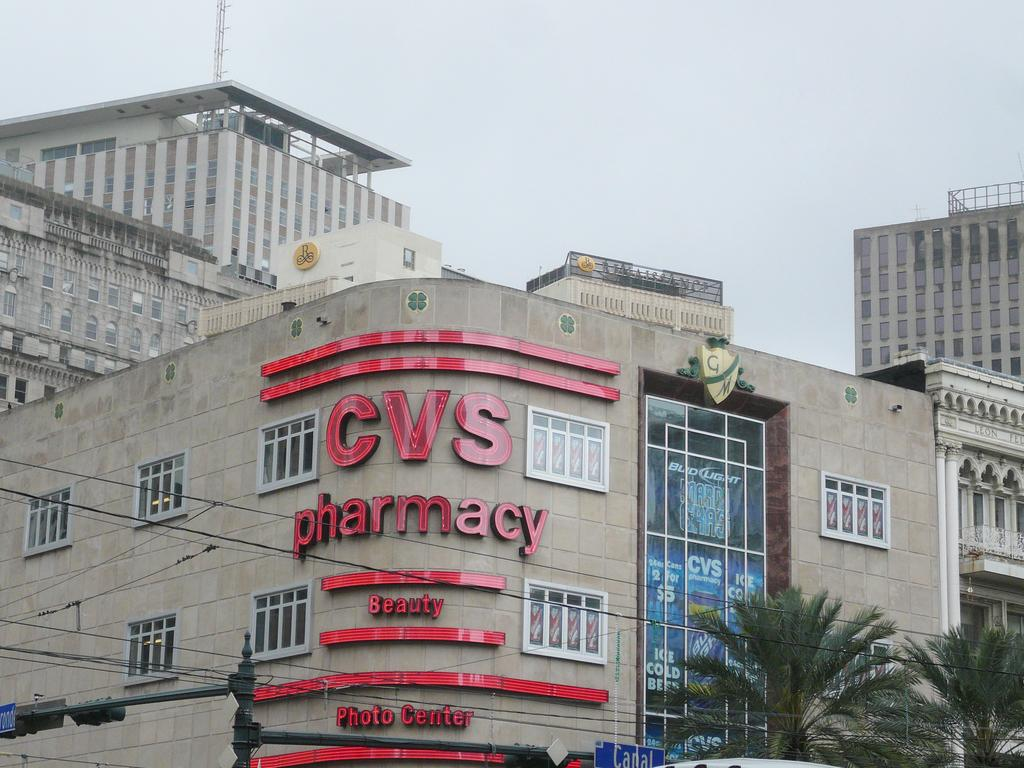What type of structures can be seen in the image? There are buildings in the image. What is located in the front of the image? There are trees and wires in the front of the image. What is visible at the top of the image? The sky is visible at the top of the image. How many times does the baby sneeze in the image? There is no baby present in the image, so it is not possible to determine how many times the baby sneezes. 